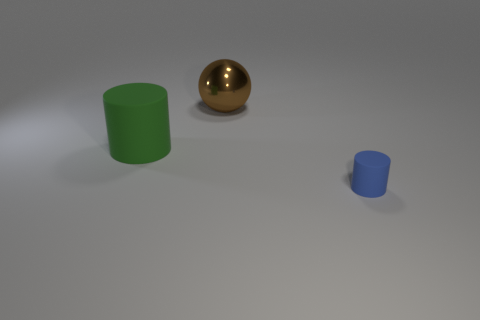Add 3 balls. How many objects exist? 6 Subtract all spheres. How many objects are left? 2 Subtract all cylinders. Subtract all small blue matte objects. How many objects are left? 0 Add 1 big brown metallic spheres. How many big brown metallic spheres are left? 2 Add 2 large red matte things. How many large red matte things exist? 2 Subtract 0 purple cylinders. How many objects are left? 3 